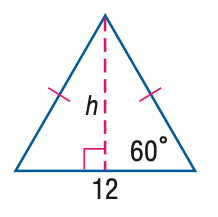Question: Find h in the triangle.
Choices:
A. 3 \sqrt 3
B. 6
C. 6 \sqrt 2
D. 6 \sqrt 3
Answer with the letter. Answer: D 